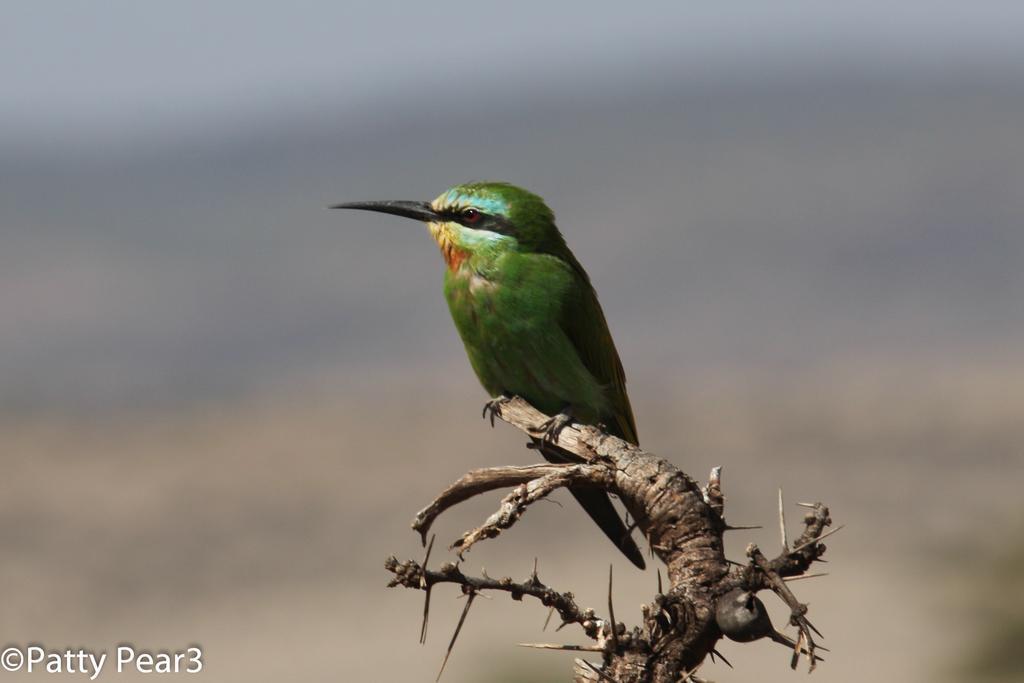Can you describe this image briefly? In this image I can see a bird on a stem. The background is blurred. In the bottom left there is some edited text. 